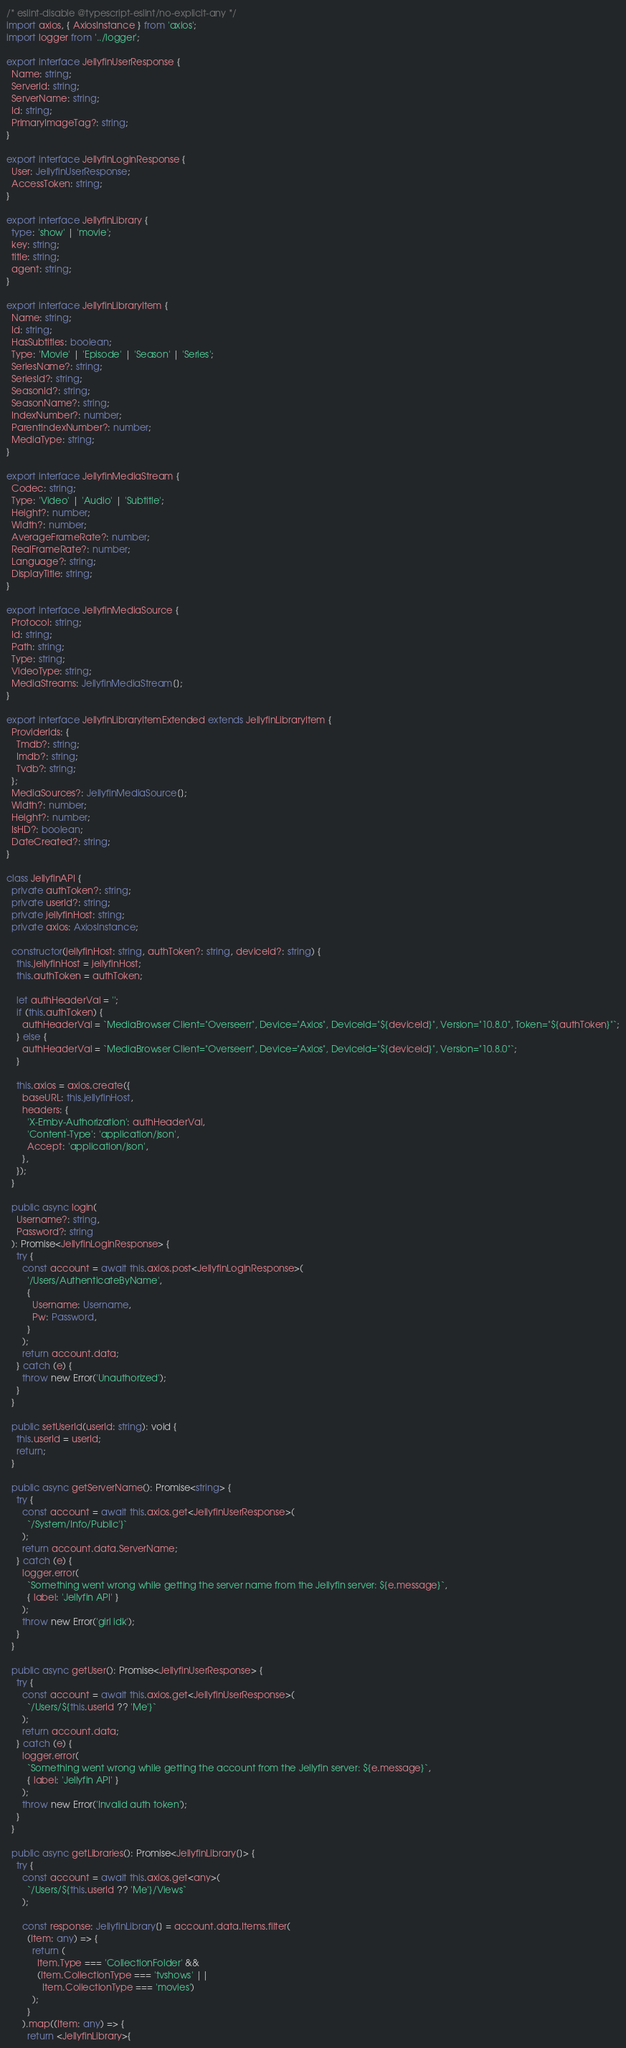Convert code to text. <code><loc_0><loc_0><loc_500><loc_500><_TypeScript_>/* eslint-disable @typescript-eslint/no-explicit-any */
import axios, { AxiosInstance } from 'axios';
import logger from '../logger';

export interface JellyfinUserResponse {
  Name: string;
  ServerId: string;
  ServerName: string;
  Id: string;
  PrimaryImageTag?: string;
}

export interface JellyfinLoginResponse {
  User: JellyfinUserResponse;
  AccessToken: string;
}

export interface JellyfinLibrary {
  type: 'show' | 'movie';
  key: string;
  title: string;
  agent: string;
}

export interface JellyfinLibraryItem {
  Name: string;
  Id: string;
  HasSubtitles: boolean;
  Type: 'Movie' | 'Episode' | 'Season' | 'Series';
  SeriesName?: string;
  SeriesId?: string;
  SeasonId?: string;
  SeasonName?: string;
  IndexNumber?: number;
  ParentIndexNumber?: number;
  MediaType: string;
}

export interface JellyfinMediaStream {
  Codec: string;
  Type: 'Video' | 'Audio' | 'Subtitle';
  Height?: number;
  Width?: number;
  AverageFrameRate?: number;
  RealFrameRate?: number;
  Language?: string;
  DisplayTitle: string;
}

export interface JellyfinMediaSource {
  Protocol: string;
  Id: string;
  Path: string;
  Type: string;
  VideoType: string;
  MediaStreams: JellyfinMediaStream[];
}

export interface JellyfinLibraryItemExtended extends JellyfinLibraryItem {
  ProviderIds: {
    Tmdb?: string;
    Imdb?: string;
    Tvdb?: string;
  };
  MediaSources?: JellyfinMediaSource[];
  Width?: number;
  Height?: number;
  IsHD?: boolean;
  DateCreated?: string;
}

class JellyfinAPI {
  private authToken?: string;
  private userId?: string;
  private jellyfinHost: string;
  private axios: AxiosInstance;

  constructor(jellyfinHost: string, authToken?: string, deviceId?: string) {
    this.jellyfinHost = jellyfinHost;
    this.authToken = authToken;

    let authHeaderVal = '';
    if (this.authToken) {
      authHeaderVal = `MediaBrowser Client="Overseerr", Device="Axios", DeviceId="${deviceId}", Version="10.8.0", Token="${authToken}"`;
    } else {
      authHeaderVal = `MediaBrowser Client="Overseerr", Device="Axios", DeviceId="${deviceId}", Version="10.8.0"`;
    }

    this.axios = axios.create({
      baseURL: this.jellyfinHost,
      headers: {
        'X-Emby-Authorization': authHeaderVal,
        'Content-Type': 'application/json',
        Accept: 'application/json',
      },
    });
  }

  public async login(
    Username?: string,
    Password?: string
  ): Promise<JellyfinLoginResponse> {
    try {
      const account = await this.axios.post<JellyfinLoginResponse>(
        '/Users/AuthenticateByName',
        {
          Username: Username,
          Pw: Password,
        }
      );
      return account.data;
    } catch (e) {
      throw new Error('Unauthorized');
    }
  }

  public setUserId(userId: string): void {
    this.userId = userId;
    return;
  }

  public async getServerName(): Promise<string> {
    try {
      const account = await this.axios.get<JellyfinUserResponse>(
        `/System/Info/Public'}`
      );
      return account.data.ServerName;
    } catch (e) {
      logger.error(
        `Something went wrong while getting the server name from the Jellyfin server: ${e.message}`,
        { label: 'Jellyfin API' }
      );
      throw new Error('girl idk');
    }
  }

  public async getUser(): Promise<JellyfinUserResponse> {
    try {
      const account = await this.axios.get<JellyfinUserResponse>(
        `/Users/${this.userId ?? 'Me'}`
      );
      return account.data;
    } catch (e) {
      logger.error(
        `Something went wrong while getting the account from the Jellyfin server: ${e.message}`,
        { label: 'Jellyfin API' }
      );
      throw new Error('Invalid auth token');
    }
  }

  public async getLibraries(): Promise<JellyfinLibrary[]> {
    try {
      const account = await this.axios.get<any>(
        `/Users/${this.userId ?? 'Me'}/Views`
      );

      const response: JellyfinLibrary[] = account.data.Items.filter(
        (Item: any) => {
          return (
            Item.Type === 'CollectionFolder' &&
            (Item.CollectionType === 'tvshows' ||
              Item.CollectionType === 'movies')
          );
        }
      ).map((Item: any) => {
        return <JellyfinLibrary>{</code> 